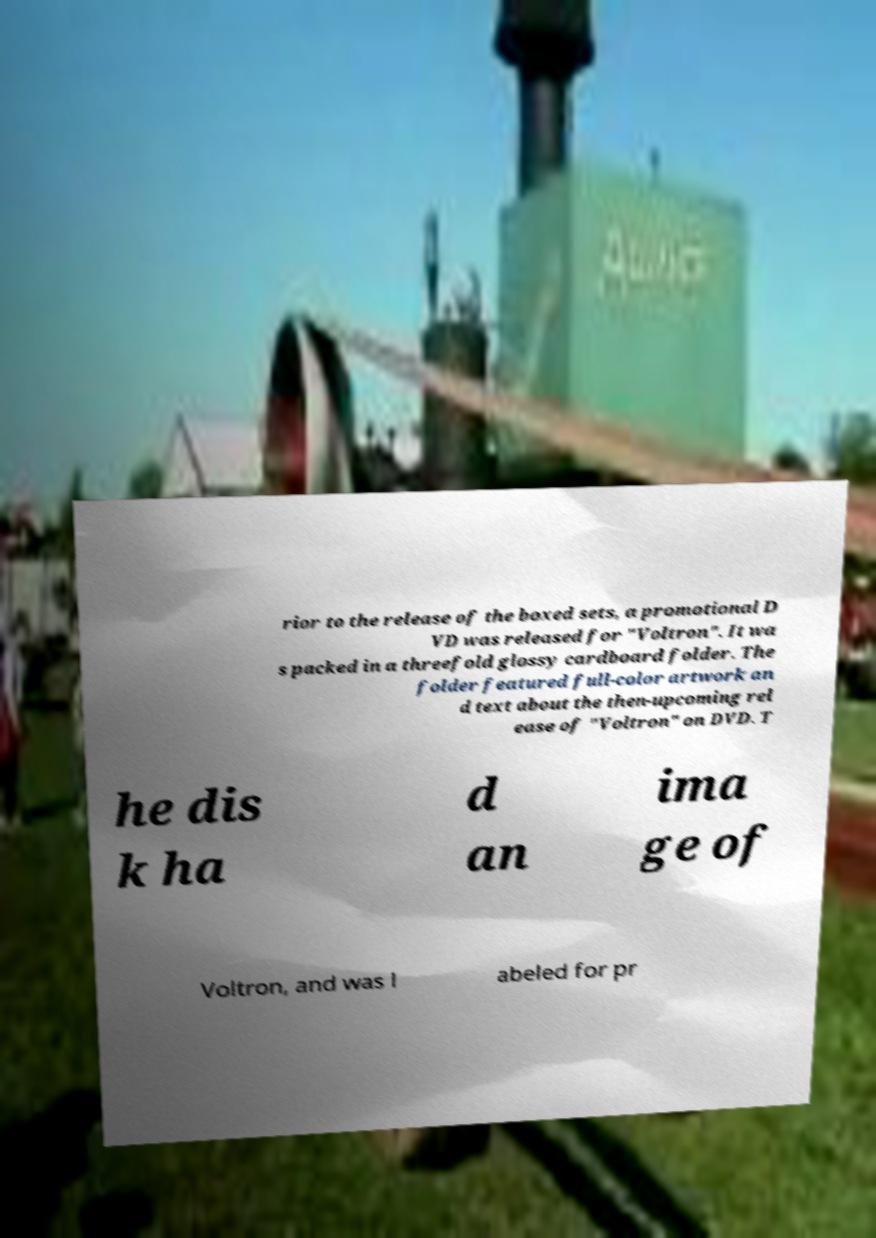Please read and relay the text visible in this image. What does it say? rior to the release of the boxed sets, a promotional D VD was released for "Voltron". It wa s packed in a threefold glossy cardboard folder. The folder featured full-color artwork an d text about the then-upcoming rel ease of "Voltron" on DVD. T he dis k ha d an ima ge of Voltron, and was l abeled for pr 